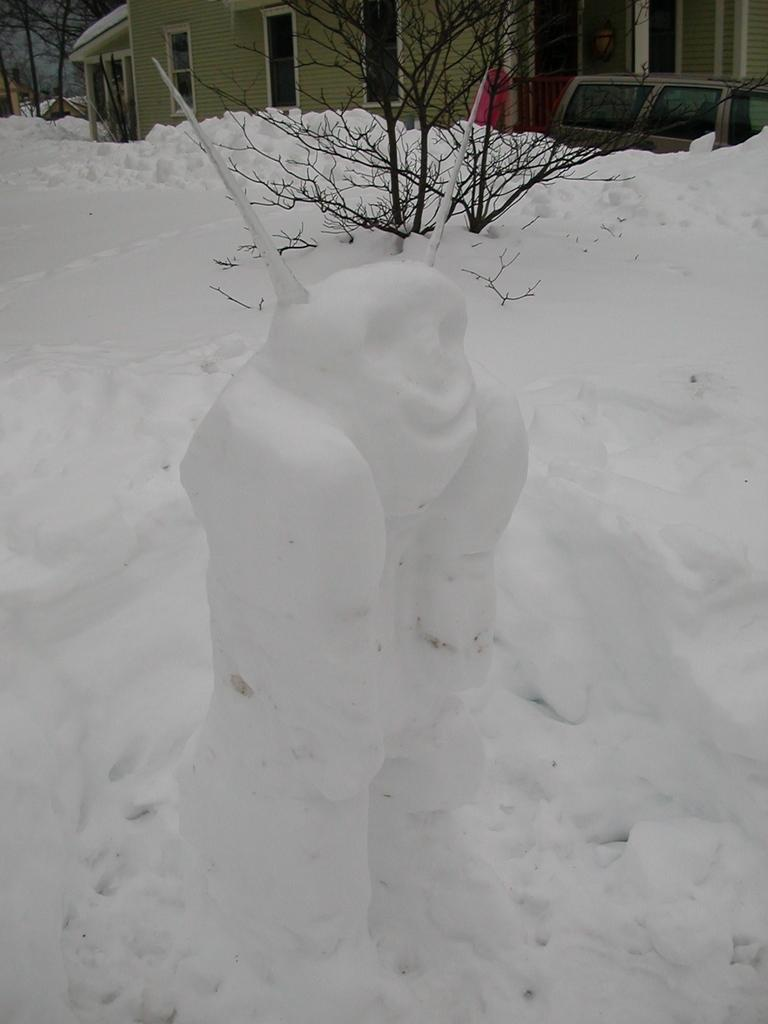What is the main subject of the image? There is a snow statue in the image. Where is the snow statue located? The snow statue is on the snow. What can be seen in the background of the image? There are trees visible at the top of the image. What type of structure is present in the image? There is a house in the image. What architectural feature is present in the image? There is a wall in the image. What part of the house is visible in the image? There are windows in the image. What else is present in the image? There is a vehicle in the image. What type of toothbrush is the snow statue using in the image? There is no toothbrush present in the image, as the main subject is a snow statue. 